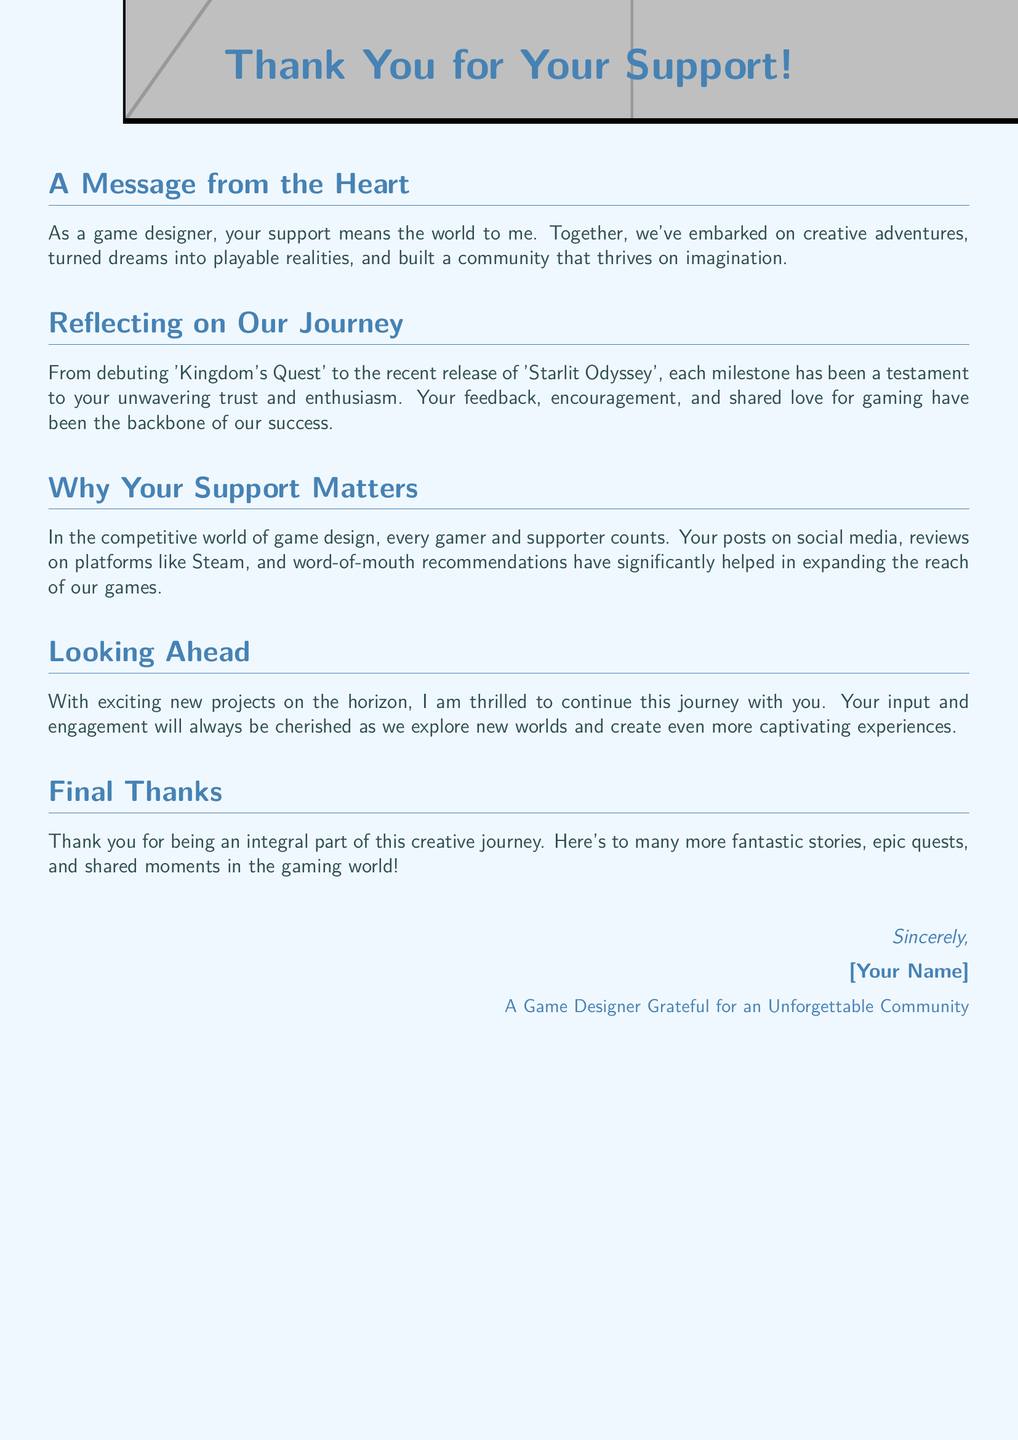What is the title of the document? The title is prominently displayed at the top of the document, indicating the main theme of gratitude.
Answer: Thank You for Your Support! Who is the message from? The closing section of the document identifies the sender of the message, adding a personal touch.
Answer: [Your Name] What game is mentioned as a debut? The document references a specific game that marked the start of the sender's journey in game design.
Answer: Kingdom's Quest What is one way the supporters have helped? It elaborates on the types of support received from the community, indicating their impact on the sender's work.
Answer: Word-of-mouth recommendations What is the main emotional tone of the message? The document conveys a heartfelt tone throughout, reflecting the importance of support to the sender.
Answer: Grateful How many games are mentioned in the document? The document refers to two specific games, showcasing the sender's journey in game design.
Answer: Two What color is used for the main title? The document uses a specific color to highlight the title, making it visually appealing.
Answer: Headercolor How does the sender feel about the supporters? The overall sentiment expressed in the document conveys appreciation and acknowledgment of the supporters' role.
Answer: Integral part 